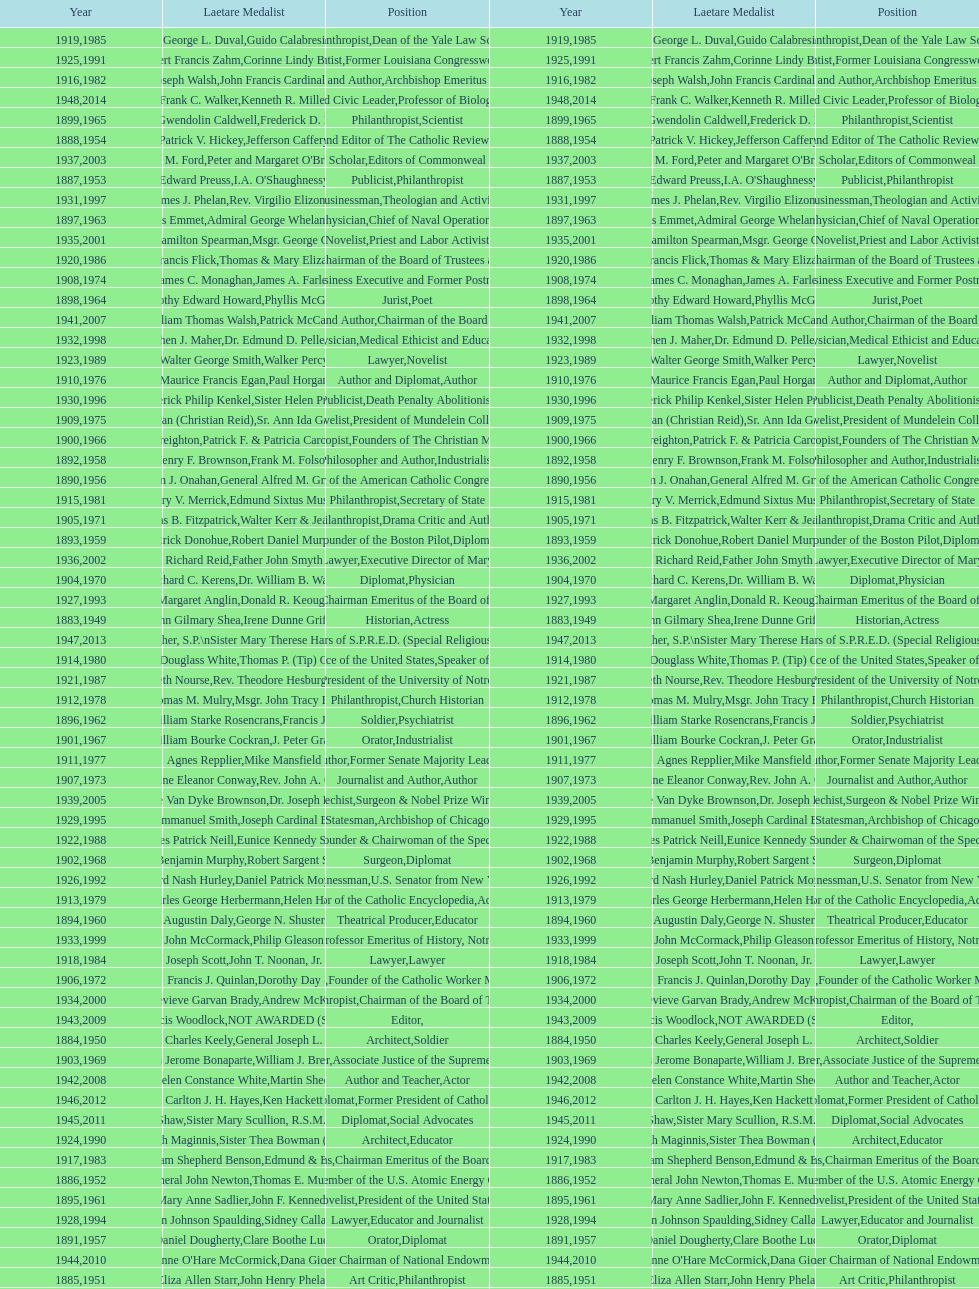Among laetare medalists, how many were involved in philanthropy? 2. 